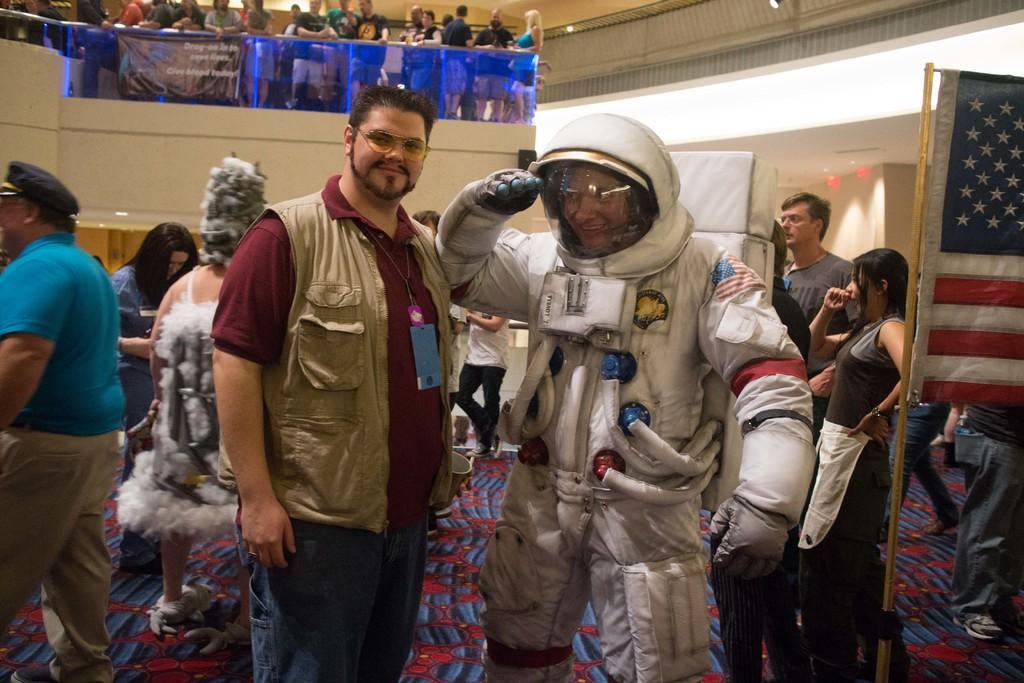Describe this image in one or two sentences. In this image there is a person in the middle who is wearing the space jacket. On the right side there is a flag. On the left side there is a person standing on the floor who is wearing an id card. At the top there are few people standing on the floor. In the background there are few people standing on the mat. 